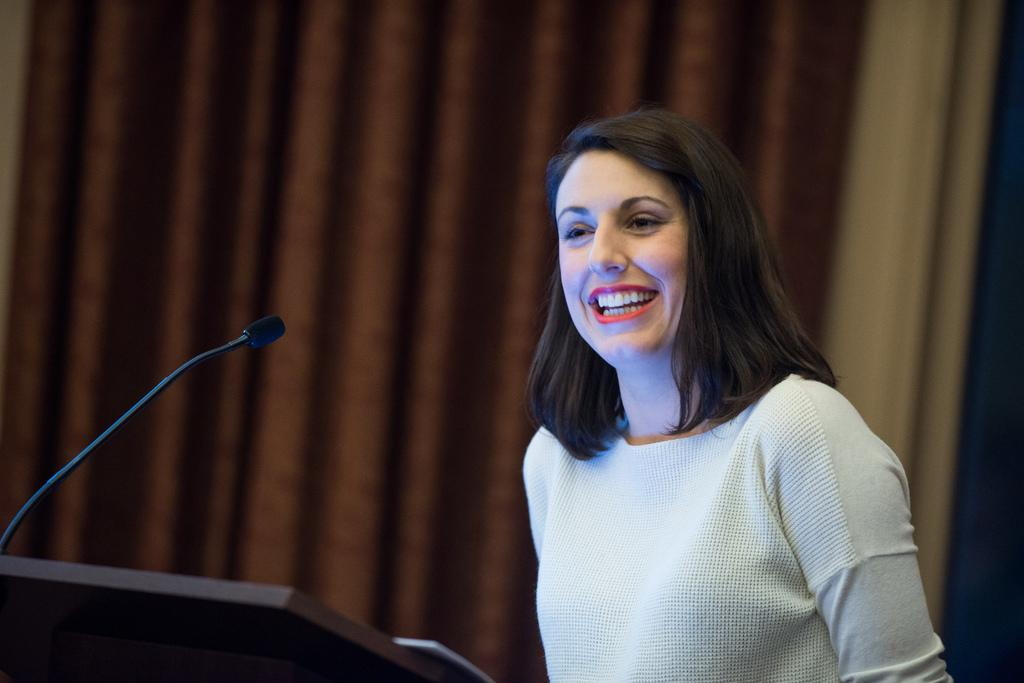Who is present in the image? There is a woman in the image. What is the woman doing in the image? The woman is smiling in the image. What object is in front of the woman? There is a microphone in front of the woman. What color is the zebra in the image? There is no zebra present in the image. 